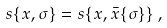Convert formula to latex. <formula><loc_0><loc_0><loc_500><loc_500>s \{ x , \sigma \} = s \{ x , \bar { x } \{ \sigma \} \} \, ,</formula> 